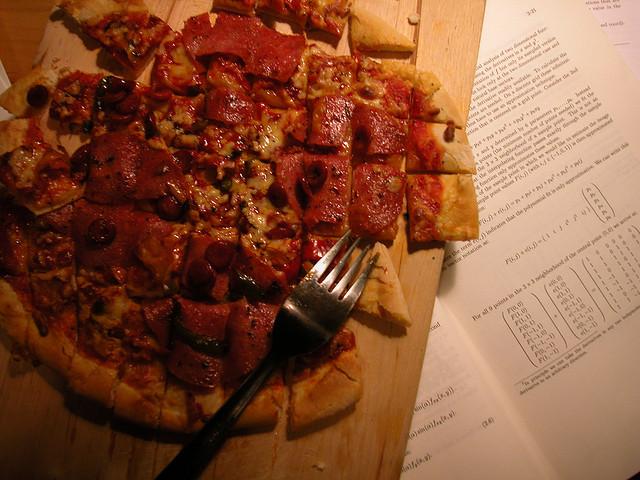Is the fork upside down or right side up?
Be succinct. Upside down. Why is the pizza cut up?
Keep it brief. To eat. Are the round items on the pizza usually salty?
Answer briefly. Yes. 